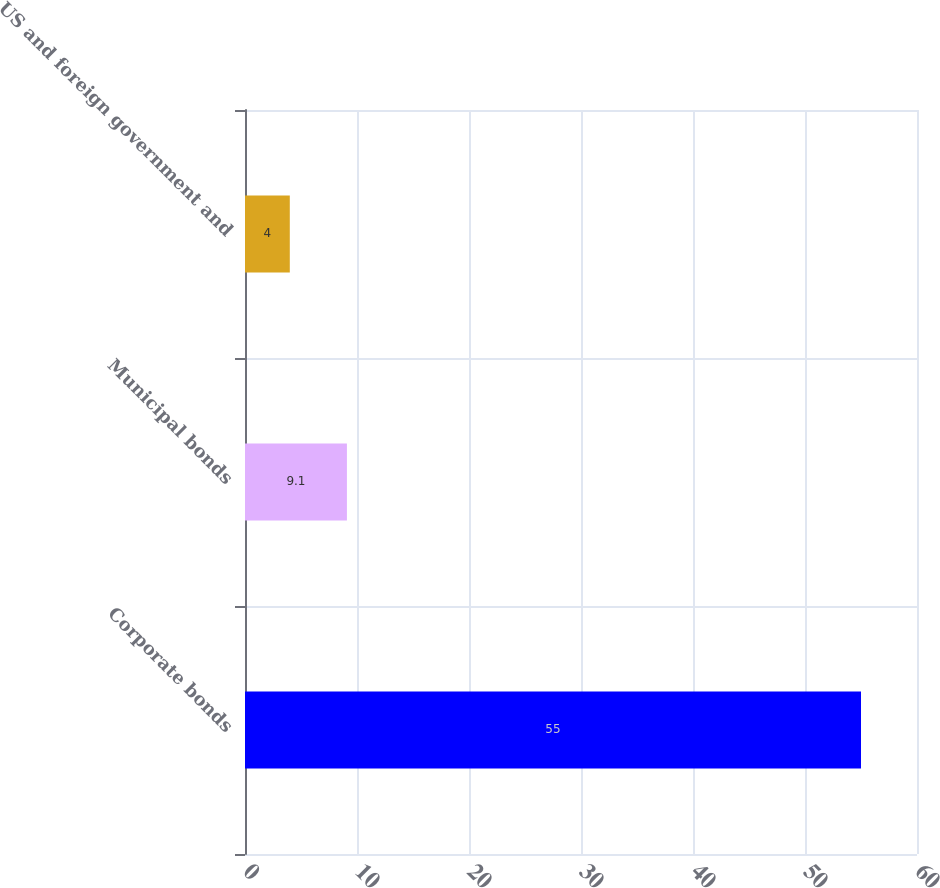<chart> <loc_0><loc_0><loc_500><loc_500><bar_chart><fcel>Corporate bonds<fcel>Municipal bonds<fcel>US and foreign government and<nl><fcel>55<fcel>9.1<fcel>4<nl></chart> 